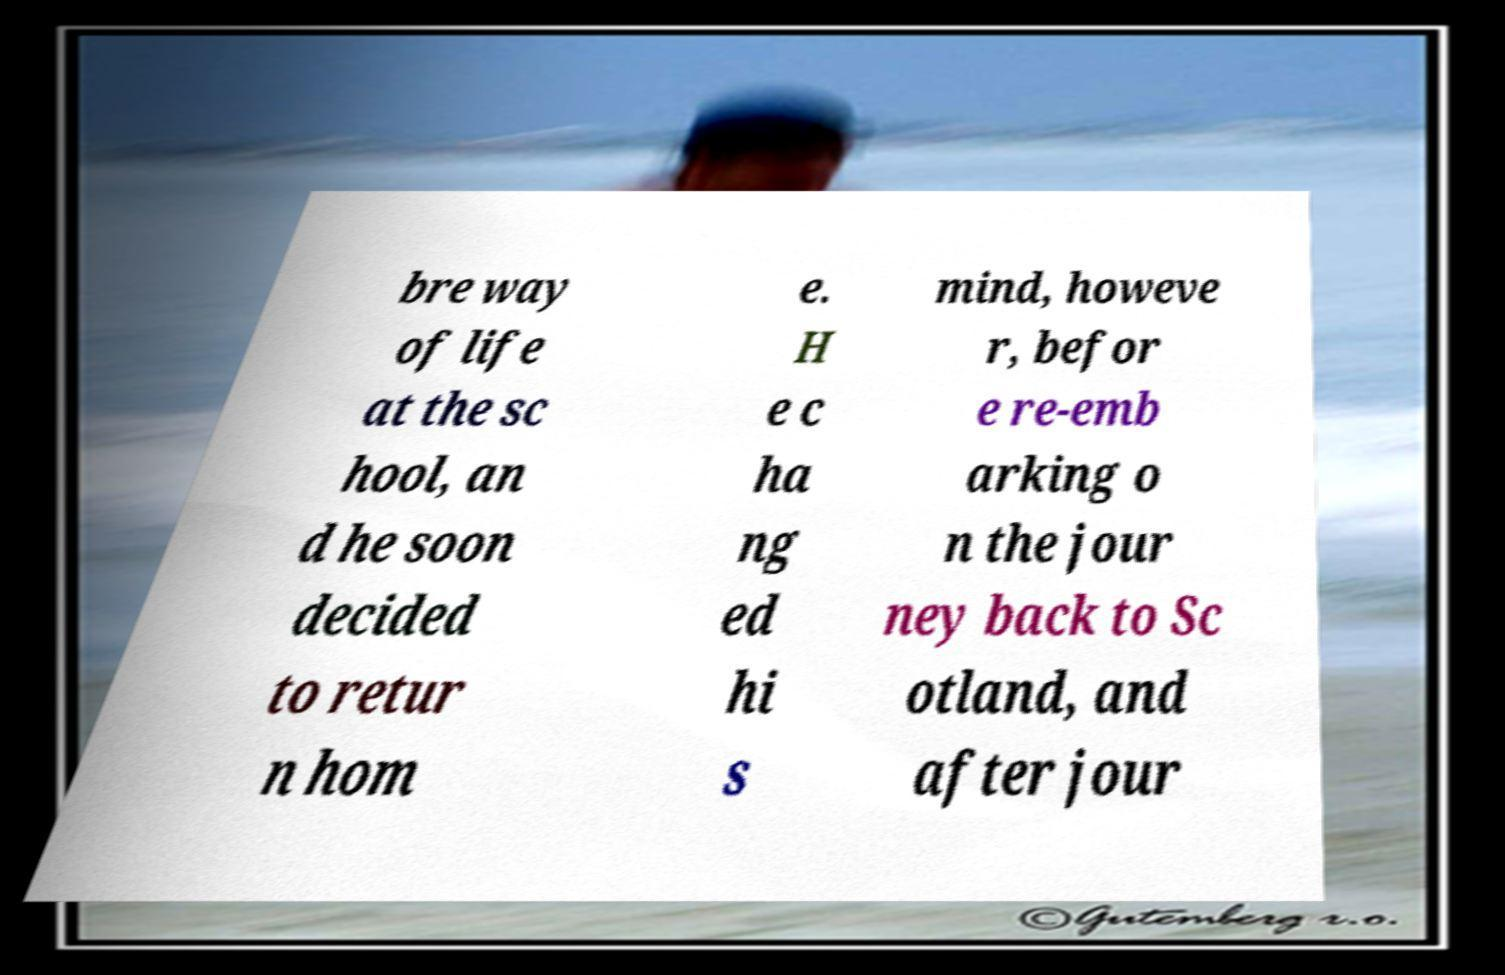For documentation purposes, I need the text within this image transcribed. Could you provide that? bre way of life at the sc hool, an d he soon decided to retur n hom e. H e c ha ng ed hi s mind, howeve r, befor e re-emb arking o n the jour ney back to Sc otland, and after jour 